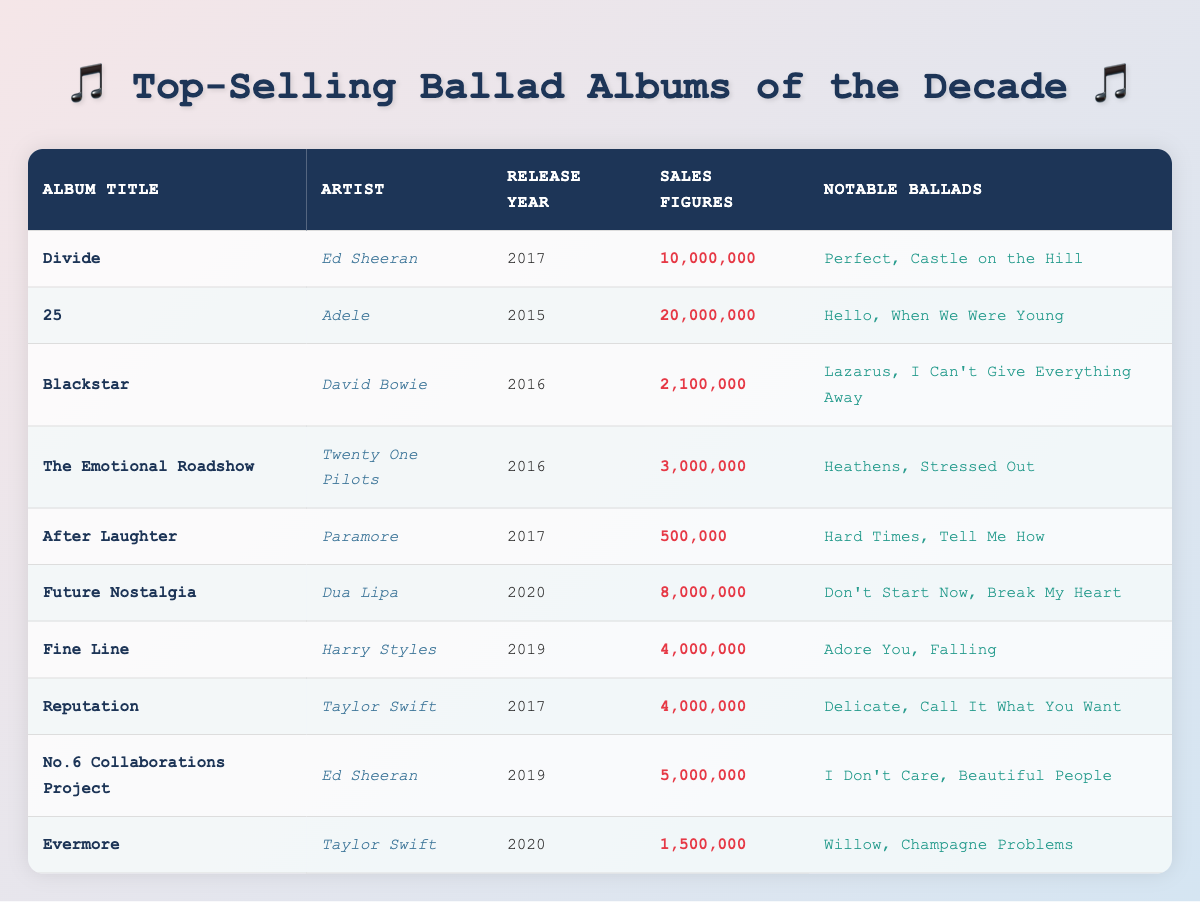What is the best-selling album in the table? The album "25" by Adele has the highest sales figures at 20,000,000, making it the best-selling album in the table.
Answer: 25 Which artist has the most albums listed in the table? Ed Sheeran appears twice in the table with the albums "Divide" and "No.6 Collaborations Project," making him the artist with the most albums listed.
Answer: Ed Sheeran What is the average sales figure for albums released in 2017? The albums released in 2017 are "Divide" (10,000,000), "After Laughter" (500,000), and "Reputation" (4,000,000). The average is calculated as (10,000,000 + 500,000 + 4,000,000) / 3 = 4,833,333.
Answer: 4,833,333 Did Taylor Swift release more than one ballad album in the last decade? Yes, Taylor Swift has two albums listed: "Reputation" and "Evermore," indicating she has released more than one ballad album in the last decade.
Answer: Yes Which album has the least sales figures? "After Laughter" by Paramore has the lowest sales figures at 500,000, making it the album with the least sales in the table.
Answer: After Laughter What is the total sales figure of the albums released by Ed Sheeran? Ed Sheeran's albums "Divide" (10,000,000) and "No.6 Collaborations Project" (5,000,000) have total sales of 10,000,000 + 5,000,000 = 15,000,000.
Answer: 15,000,000 Among the albums listed, which artist released the album in 2016 with the highest sales figures? "Blackstar" by David Bowie was released in 2016 and had sales figures of 2,100,000. "The Emotional Roadshow" by Twenty One Pilots also released in 2016 had 3,000,000 in sales. Therefore, "The Emotional Roadshow" had the highest sales in 2016.
Answer: The Emotional Roadshow How many notable ballads does Dua Lipa's "Future Nostalgia" have? Dua Lipa's "Future Nostalgia" has two notable ballads listed: "Don't Start Now" and "Break My Heart."
Answer: 2 What year did the album with the highest sales come out? The album "25" by Adele, which has the highest sales, was released in 2015. Therefore, the year of that album's release is 2015.
Answer: 2015 